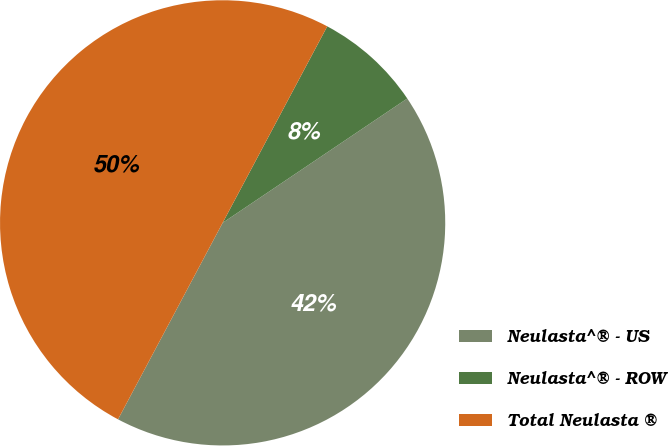<chart> <loc_0><loc_0><loc_500><loc_500><pie_chart><fcel>Neulasta^® - US<fcel>Neulasta^® - ROW<fcel>Total Neulasta ®<nl><fcel>42.22%<fcel>7.78%<fcel>50.0%<nl></chart> 